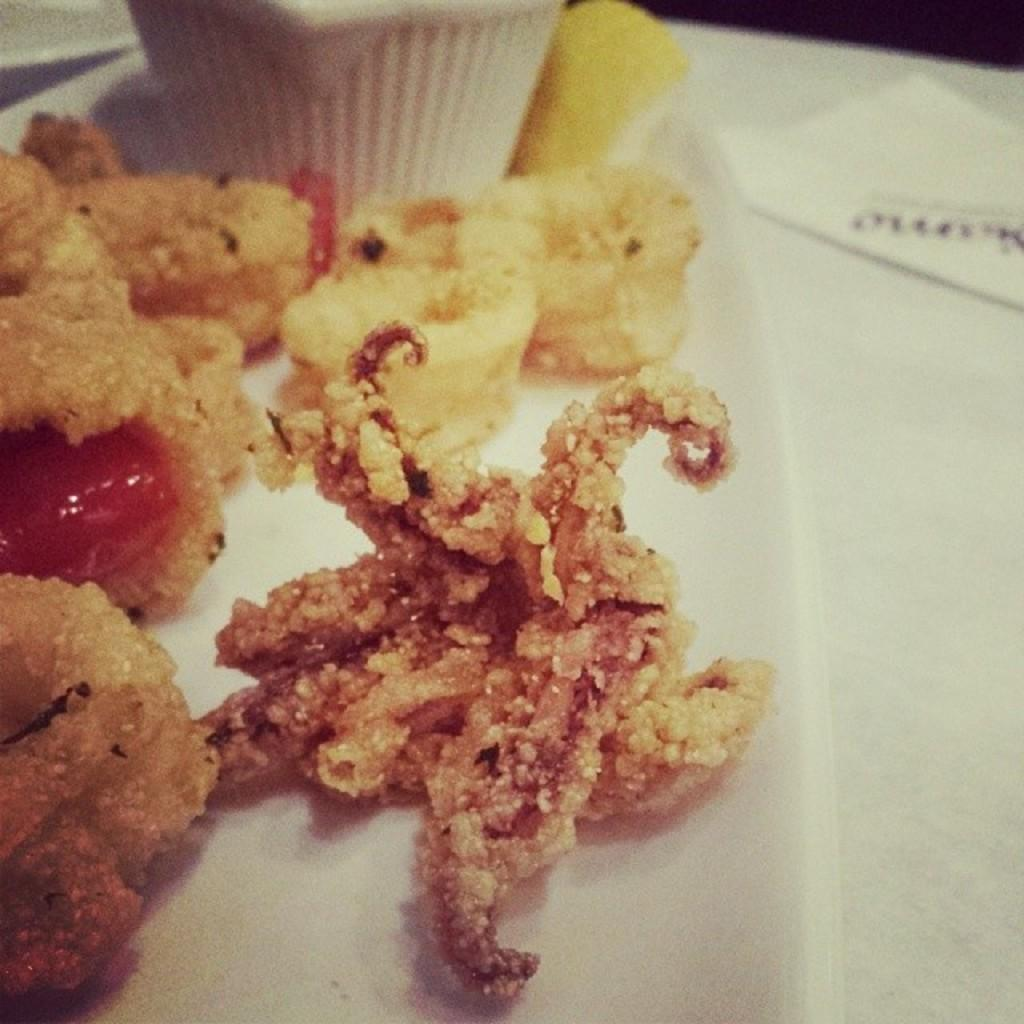What type of food can be seen in the image? The food in the image has brown and red colors. On what surface is the food placed? The food is on some surface. What can be seen in the background of the image? There is a white color cup and papers in the background. What type of fiction is being read by the carriage in the harbor in the image? There is no carriage or harbor present in the image; it features food with brown and red colors on a surface, along with a white cup and papers in the background. 